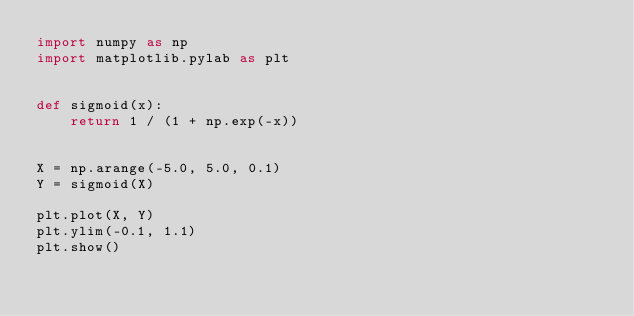<code> <loc_0><loc_0><loc_500><loc_500><_Python_>import numpy as np
import matplotlib.pylab as plt


def sigmoid(x):
    return 1 / (1 + np.exp(-x))


X = np.arange(-5.0, 5.0, 0.1)
Y = sigmoid(X)

plt.plot(X, Y)
plt.ylim(-0.1, 1.1)
plt.show()
</code> 